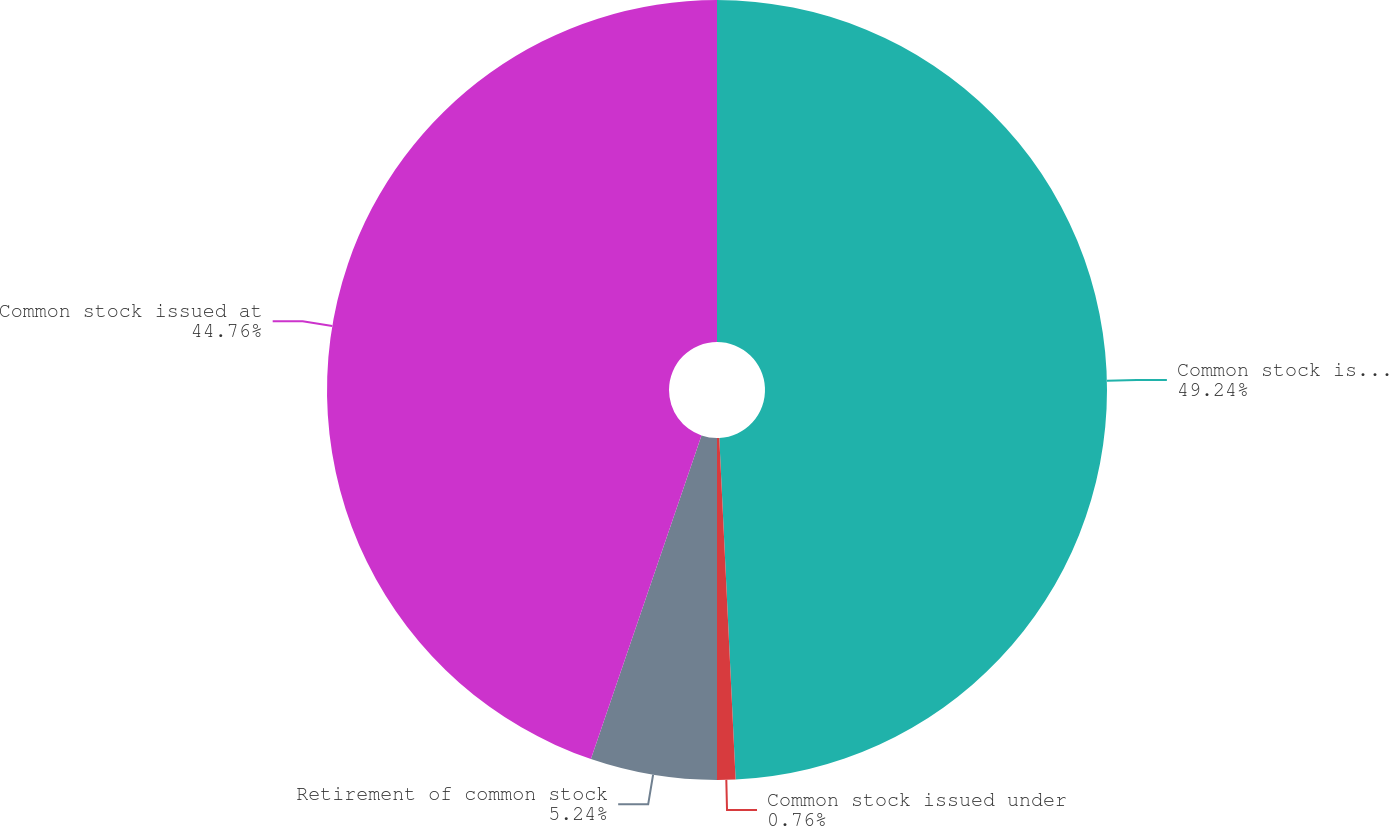Convert chart. <chart><loc_0><loc_0><loc_500><loc_500><pie_chart><fcel>Common stock issued at January<fcel>Common stock issued under<fcel>Retirement of common stock<fcel>Common stock issued at<nl><fcel>49.24%<fcel>0.76%<fcel>5.24%<fcel>44.76%<nl></chart> 